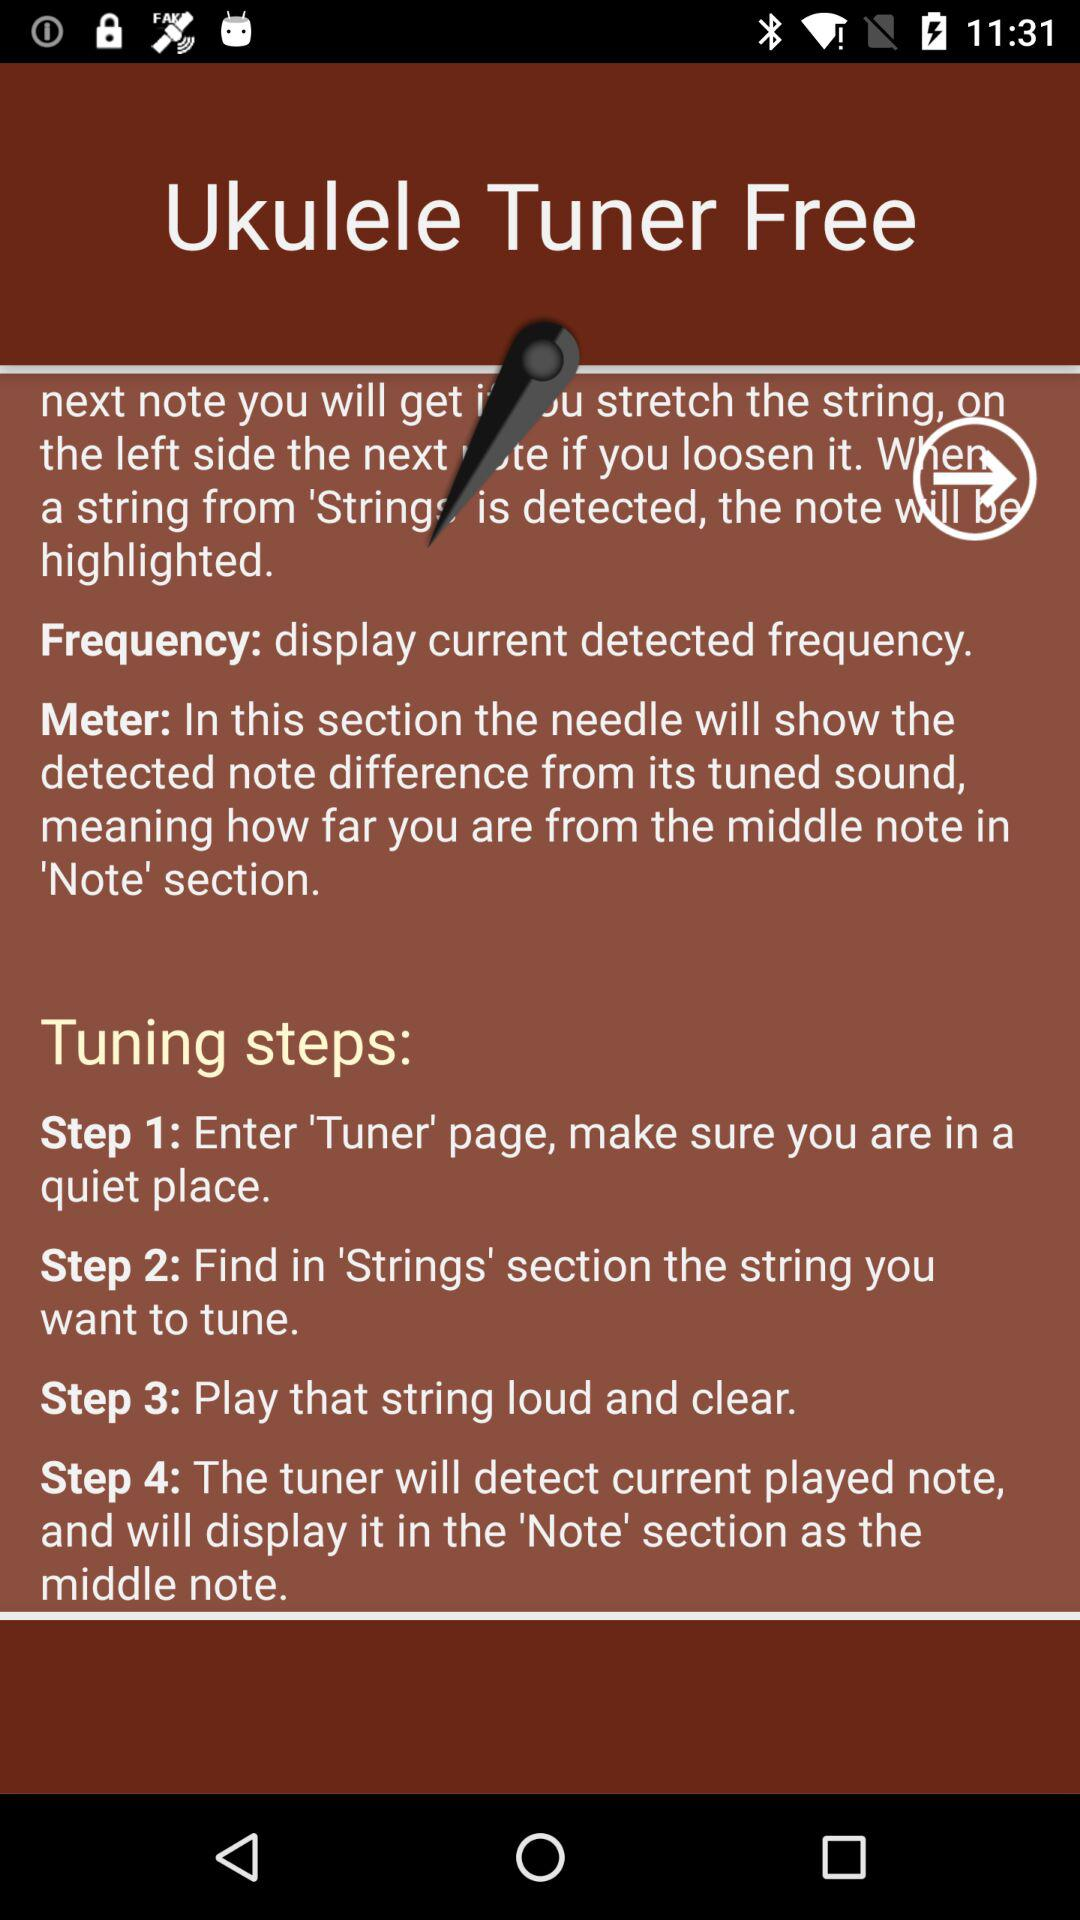How many steps does the tuning process have?
Answer the question using a single word or phrase. 4 